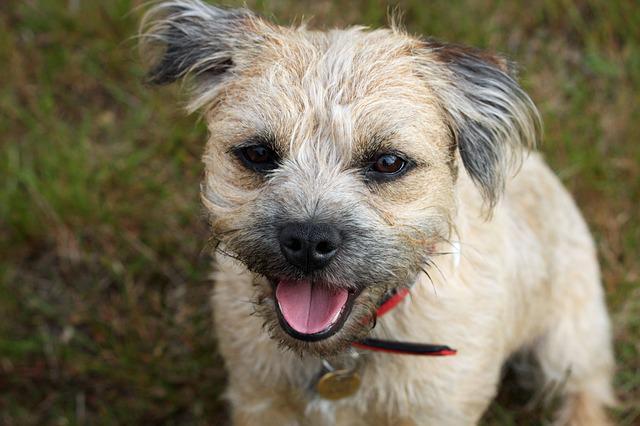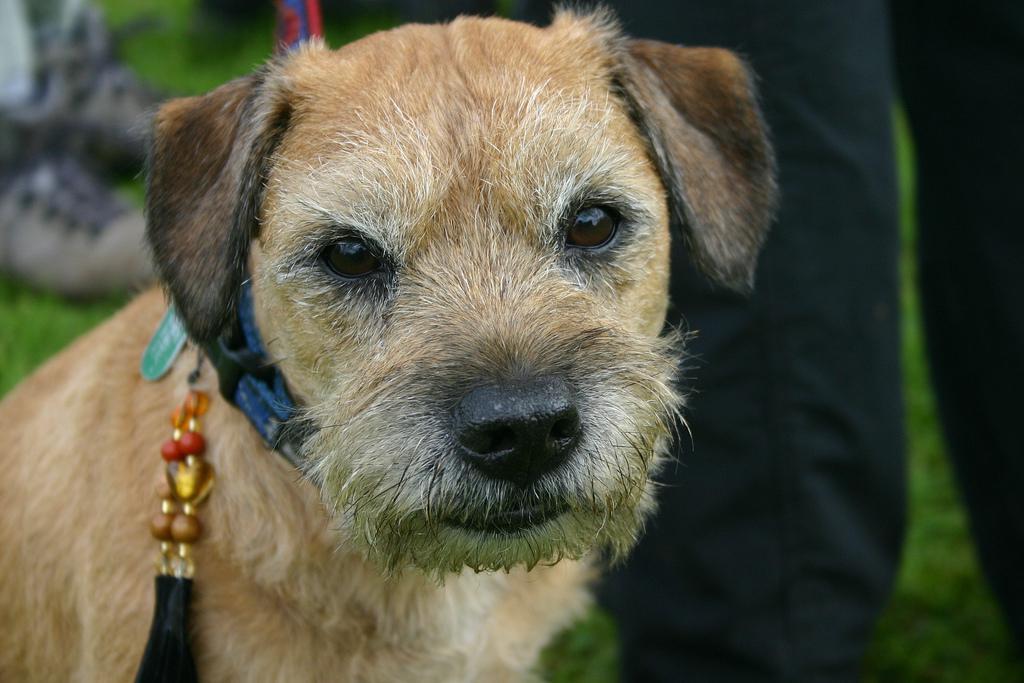The first image is the image on the left, the second image is the image on the right. Considering the images on both sides, is "There is some green grass in the background of every image." valid? Answer yes or no. Yes. The first image is the image on the left, the second image is the image on the right. Examine the images to the left and right. Is the description "The dog on the right has a blue collar" accurate? Answer yes or no. Yes. 